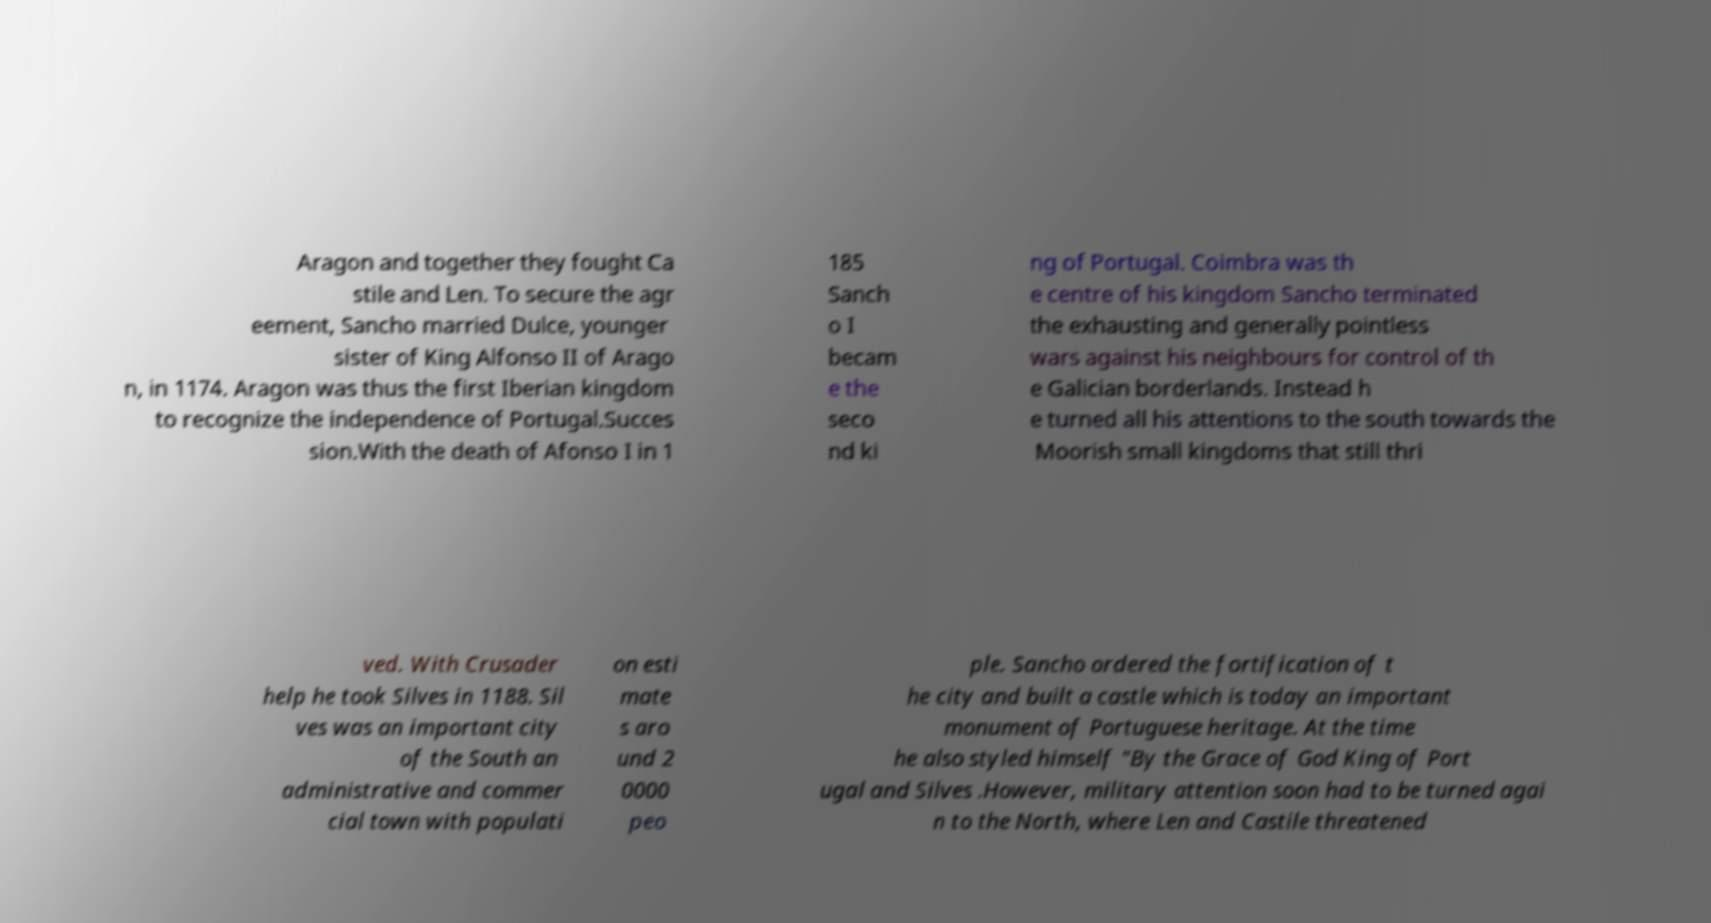Can you read and provide the text displayed in the image?This photo seems to have some interesting text. Can you extract and type it out for me? Aragon and together they fought Ca stile and Len. To secure the agr eement, Sancho married Dulce, younger sister of King Alfonso II of Arago n, in 1174. Aragon was thus the first Iberian kingdom to recognize the independence of Portugal.Succes sion.With the death of Afonso I in 1 185 Sanch o I becam e the seco nd ki ng of Portugal. Coimbra was th e centre of his kingdom Sancho terminated the exhausting and generally pointless wars against his neighbours for control of th e Galician borderlands. Instead h e turned all his attentions to the south towards the Moorish small kingdoms that still thri ved. With Crusader help he took Silves in 1188. Sil ves was an important city of the South an administrative and commer cial town with populati on esti mate s aro und 2 0000 peo ple. Sancho ordered the fortification of t he city and built a castle which is today an important monument of Portuguese heritage. At the time he also styled himself "By the Grace of God King of Port ugal and Silves .However, military attention soon had to be turned agai n to the North, where Len and Castile threatened 